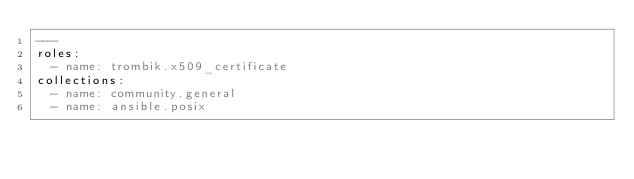Convert code to text. <code><loc_0><loc_0><loc_500><loc_500><_YAML_>---
roles:
  - name: trombik.x509_certificate
collections:
  - name: community.general
  - name: ansible.posix
</code> 